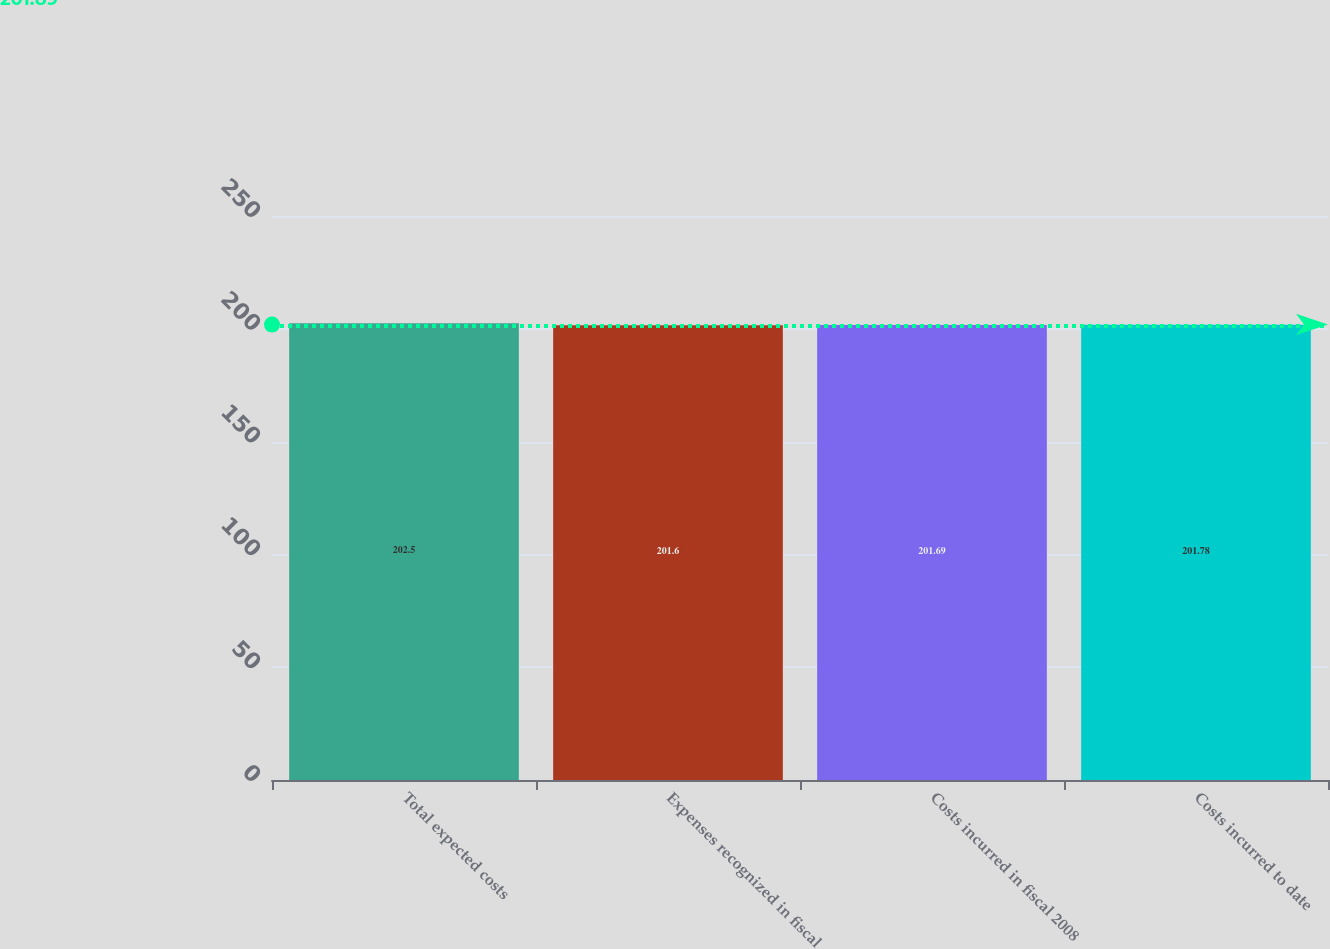Convert chart to OTSL. <chart><loc_0><loc_0><loc_500><loc_500><bar_chart><fcel>Total expected costs<fcel>Expenses recognized in fiscal<fcel>Costs incurred in fiscal 2008<fcel>Costs incurred to date<nl><fcel>202.5<fcel>201.6<fcel>201.69<fcel>201.78<nl></chart> 